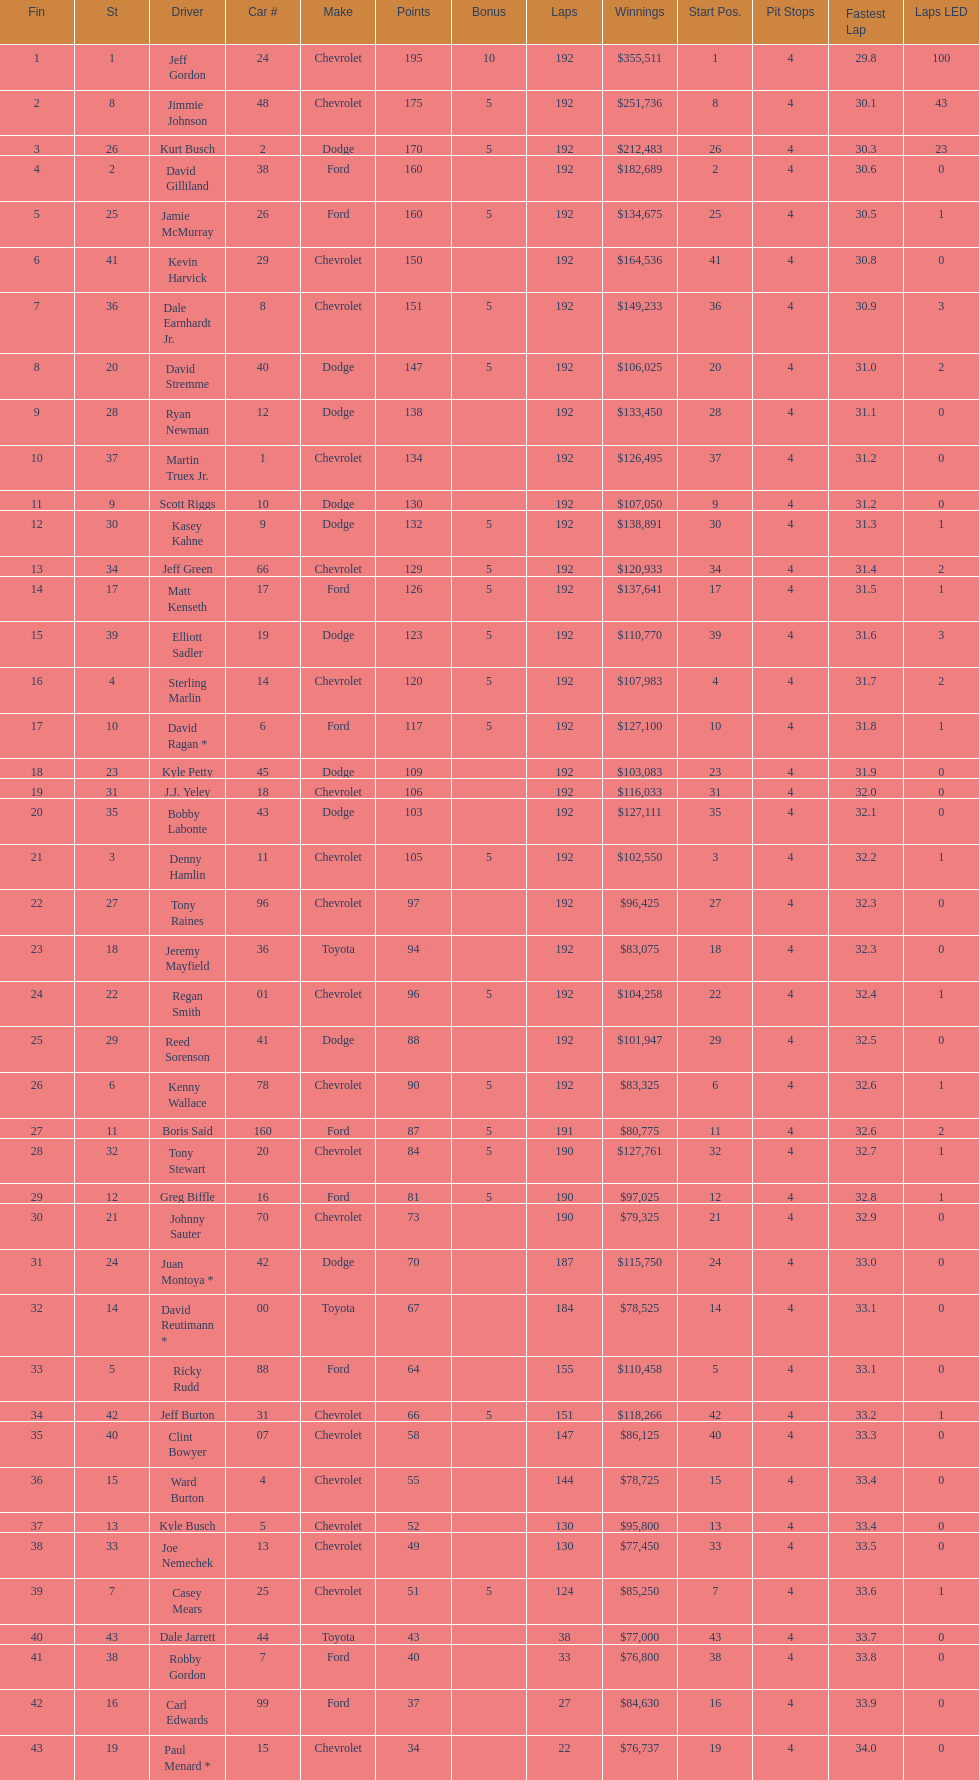Could you help me parse every detail presented in this table? {'header': ['Fin', 'St', 'Driver', 'Car #', 'Make', 'Points', 'Bonus', 'Laps', 'Winnings', 'Start Pos.', 'Pit Stops', 'Fastest Lap', 'Laps LED'], 'rows': [['1', '1', 'Jeff Gordon', '24', 'Chevrolet', '195', '10', '192', '$355,511', '1', '4', '29.8', '100'], ['2', '8', 'Jimmie Johnson', '48', 'Chevrolet', '175', '5', '192', '$251,736', '8', '4', '30.1', '43'], ['3', '26', 'Kurt Busch', '2', 'Dodge', '170', '5', '192', '$212,483', '26', '4', '30.3', '23'], ['4', '2', 'David Gilliland', '38', 'Ford', '160', '', '192', '$182,689', '2', '4', '30.6', '0'], ['5', '25', 'Jamie McMurray', '26', 'Ford', '160', '5', '192', '$134,675', '25', '4', '30.5', '1'], ['6', '41', 'Kevin Harvick', '29', 'Chevrolet', '150', '', '192', '$164,536', '41', '4', '30.8', '0'], ['7', '36', 'Dale Earnhardt Jr.', '8', 'Chevrolet', '151', '5', '192', '$149,233', '36', '4', '30.9', '3'], ['8', '20', 'David Stremme', '40', 'Dodge', '147', '5', '192', '$106,025', '20', '4', '31.0', '2'], ['9', '28', 'Ryan Newman', '12', 'Dodge', '138', '', '192', '$133,450', '28', '4', '31.1', '0'], ['10', '37', 'Martin Truex Jr.', '1', 'Chevrolet', '134', '', '192', '$126,495', '37', '4', '31.2', '0'], ['11', '9', 'Scott Riggs', '10', 'Dodge', '130', '', '192', '$107,050', '9', '4', '31.2', '0'], ['12', '30', 'Kasey Kahne', '9', 'Dodge', '132', '5', '192', '$138,891', '30', '4', '31.3', '1'], ['13', '34', 'Jeff Green', '66', 'Chevrolet', '129', '5', '192', '$120,933', '34', '4', '31.4', '2'], ['14', '17', 'Matt Kenseth', '17', 'Ford', '126', '5', '192', '$137,641', '17', '4', '31.5', '1'], ['15', '39', 'Elliott Sadler', '19', 'Dodge', '123', '5', '192', '$110,770', '39', '4', '31.6', '3'], ['16', '4', 'Sterling Marlin', '14', 'Chevrolet', '120', '5', '192', '$107,983', '4', '4', '31.7', '2'], ['17', '10', 'David Ragan *', '6', 'Ford', '117', '5', '192', '$127,100', '10', '4', '31.8', '1'], ['18', '23', 'Kyle Petty', '45', 'Dodge', '109', '', '192', '$103,083', '23', '4', '31.9', '0'], ['19', '31', 'J.J. Yeley', '18', 'Chevrolet', '106', '', '192', '$116,033', '31', '4', '32.0', '0'], ['20', '35', 'Bobby Labonte', '43', 'Dodge', '103', '', '192', '$127,111', '35', '4', '32.1', '0'], ['21', '3', 'Denny Hamlin', '11', 'Chevrolet', '105', '5', '192', '$102,550', '3', '4', '32.2', '1'], ['22', '27', 'Tony Raines', '96', 'Chevrolet', '97', '', '192', '$96,425', '27', '4', '32.3', '0'], ['23', '18', 'Jeremy Mayfield', '36', 'Toyota', '94', '', '192', '$83,075', '18', '4', '32.3', '0'], ['24', '22', 'Regan Smith', '01', 'Chevrolet', '96', '5', '192', '$104,258', '22', '4', '32.4', '1'], ['25', '29', 'Reed Sorenson', '41', 'Dodge', '88', '', '192', '$101,947', '29', '4', '32.5', '0'], ['26', '6', 'Kenny Wallace', '78', 'Chevrolet', '90', '5', '192', '$83,325', '6', '4', '32.6', '1'], ['27', '11', 'Boris Said', '160', 'Ford', '87', '5', '191', '$80,775', '11', '4', '32.6', '2'], ['28', '32', 'Tony Stewart', '20', 'Chevrolet', '84', '5', '190', '$127,761', '32', '4', '32.7', '1'], ['29', '12', 'Greg Biffle', '16', 'Ford', '81', '5', '190', '$97,025', '12', '4', '32.8', '1'], ['30', '21', 'Johnny Sauter', '70', 'Chevrolet', '73', '', '190', '$79,325', '21', '4', '32.9', '0'], ['31', '24', 'Juan Montoya *', '42', 'Dodge', '70', '', '187', '$115,750', '24', '4', '33.0', '0'], ['32', '14', 'David Reutimann *', '00', 'Toyota', '67', '', '184', '$78,525', '14', '4', '33.1', '0'], ['33', '5', 'Ricky Rudd', '88', 'Ford', '64', '', '155', '$110,458', '5', '4', '33.1', '0'], ['34', '42', 'Jeff Burton', '31', 'Chevrolet', '66', '5', '151', '$118,266', '42', '4', '33.2', '1'], ['35', '40', 'Clint Bowyer', '07', 'Chevrolet', '58', '', '147', '$86,125', '40', '4', '33.3', '0'], ['36', '15', 'Ward Burton', '4', 'Chevrolet', '55', '', '144', '$78,725', '15', '4', '33.4', '0'], ['37', '13', 'Kyle Busch', '5', 'Chevrolet', '52', '', '130', '$95,800', '13', '4', '33.4', '0'], ['38', '33', 'Joe Nemechek', '13', 'Chevrolet', '49', '', '130', '$77,450', '33', '4', '33.5', '0'], ['39', '7', 'Casey Mears', '25', 'Chevrolet', '51', '5', '124', '$85,250', '7', '4', '33.6', '1'], ['40', '43', 'Dale Jarrett', '44', 'Toyota', '43', '', '38', '$77,000', '43', '4', '33.7', '0'], ['41', '38', 'Robby Gordon', '7', 'Ford', '40', '', '33', '$76,800', '38', '4', '33.8', '0'], ['42', '16', 'Carl Edwards', '99', 'Ford', '37', '', '27', '$84,630', '16', '4', '33.9', '0'], ['43', '19', 'Paul Menard *', '15', 'Chevrolet', '34', '', '22', '$76,737', '19', '4', '34.0', '0']]} What was the make of both jeff gordon's and jimmie johnson's race car? Chevrolet. 